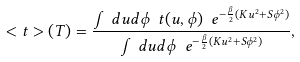Convert formula to latex. <formula><loc_0><loc_0><loc_500><loc_500>< t > ( T ) = \frac { \int d u d \phi \ t ( u , \phi ) \ e ^ { - \frac { \beta } { 2 } ( K u ^ { 2 } + S \phi ^ { 2 } ) } } { \int d u d \phi \ e ^ { - \frac { \beta } { 2 } ( K u ^ { 2 } + S \phi ^ { 2 } ) } } ,</formula> 